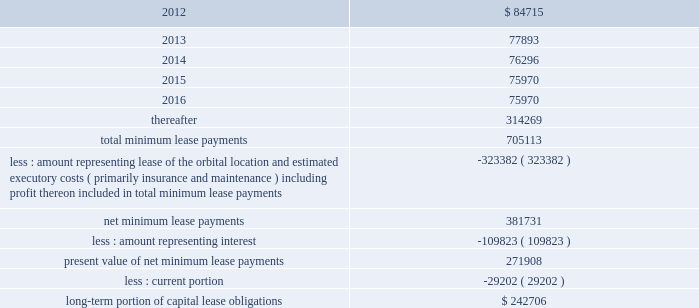Dish network corporation notes to consolidated financial statements - continued ciel ii .
Ciel ii , a canadian dbs satellite , was launched in december 2008 and commenced commercial operation during february 2009 .
This satellite is accounted for as a capital lease and depreciated over the term of the satellite service agreement .
We have leased 100% ( 100 % ) of the capacity on ciel ii for an initial 10 year term .
As of december 31 , 2011 and 2010 , we had $ 500 million capitalized for the estimated fair value of satellites acquired under capital leases included in 201cproperty and equipment , net , 201d with related accumulated depreciation of $ 151 million and $ 109 million , respectively .
In our consolidated statements of operations and comprehensive income ( loss ) , we recognized $ 43 million , $ 43 million and $ 40 million in depreciation expense on satellites acquired under capital lease agreements during the years ended december 31 , 2011 , 2010 and 2009 , respectively .
Future minimum lease payments under the capital lease obligation , together with the present value of the net minimum lease payments as of december 31 , 2011 are as follows ( in thousands ) : for the years ended december 31 .
The summary of future maturities of our outstanding long-term debt as of december 31 , 2011 is included in the commitments table in note 16 .
12 .
Income taxes and accounting for uncertainty in income taxes income taxes our income tax policy is to record the estimated future tax effects of temporary differences between the tax bases of assets and liabilities and amounts reported on our consolidated balance sheets , as well as probable operating loss , tax credit and other carryforwards .
Deferred tax assets are offset by valuation allowances when we believe it is more likely than not that net deferred tax assets will not be realized .
We periodically evaluate our need for a valuation allowance .
Determining necessary valuation allowances requires us to make assessments about historical financial information as well as the timing of future events , including the probability of expected future taxable income and available tax planning opportunities .
We file consolidated tax returns in the u.s .
The income taxes of domestic and foreign subsidiaries not included in the u.s .
Tax group are presented in our consolidated financial statements based on a separate return basis for each tax paying entity .
As of december 31 , 2011 , we had no net operating loss carryforwards ( 201cnols 201d ) for federal income tax purposes and $ 13 million of nol benefit for state income tax purposes .
The state nols begin to expire in the year 2020 .
In addition , there are $ 5 million of tax benefits related to credit carryforwards which are partially offset by a valuation allowance and $ 14 million benefit of capital loss carryforwards which are fully offset by a valuation allowance .
The credit carryforwards begin to expire in the year 2012. .
What percentage of total future minimum lease payments under the capital lease obligation is due in 2016? 
Computations: (75970 / 705113)
Answer: 0.10774. Dish network corporation notes to consolidated financial statements - continued ciel ii .
Ciel ii , a canadian dbs satellite , was launched in december 2008 and commenced commercial operation during february 2009 .
This satellite is accounted for as a capital lease and depreciated over the term of the satellite service agreement .
We have leased 100% ( 100 % ) of the capacity on ciel ii for an initial 10 year term .
As of december 31 , 2011 and 2010 , we had $ 500 million capitalized for the estimated fair value of satellites acquired under capital leases included in 201cproperty and equipment , net , 201d with related accumulated depreciation of $ 151 million and $ 109 million , respectively .
In our consolidated statements of operations and comprehensive income ( loss ) , we recognized $ 43 million , $ 43 million and $ 40 million in depreciation expense on satellites acquired under capital lease agreements during the years ended december 31 , 2011 , 2010 and 2009 , respectively .
Future minimum lease payments under the capital lease obligation , together with the present value of the net minimum lease payments as of december 31 , 2011 are as follows ( in thousands ) : for the years ended december 31 .
The summary of future maturities of our outstanding long-term debt as of december 31 , 2011 is included in the commitments table in note 16 .
12 .
Income taxes and accounting for uncertainty in income taxes income taxes our income tax policy is to record the estimated future tax effects of temporary differences between the tax bases of assets and liabilities and amounts reported on our consolidated balance sheets , as well as probable operating loss , tax credit and other carryforwards .
Deferred tax assets are offset by valuation allowances when we believe it is more likely than not that net deferred tax assets will not be realized .
We periodically evaluate our need for a valuation allowance .
Determining necessary valuation allowances requires us to make assessments about historical financial information as well as the timing of future events , including the probability of expected future taxable income and available tax planning opportunities .
We file consolidated tax returns in the u.s .
The income taxes of domestic and foreign subsidiaries not included in the u.s .
Tax group are presented in our consolidated financial statements based on a separate return basis for each tax paying entity .
As of december 31 , 2011 , we had no net operating loss carryforwards ( 201cnols 201d ) for federal income tax purposes and $ 13 million of nol benefit for state income tax purposes .
The state nols begin to expire in the year 2020 .
In addition , there are $ 5 million of tax benefits related to credit carryforwards which are partially offset by a valuation allowance and $ 14 million benefit of capital loss carryforwards which are fully offset by a valuation allowance .
The credit carryforwards begin to expire in the year 2012. .
What percentage of total future minimum lease payments under the capital lease obligation is due after 2016? 
Computations: (314269 / 705113)
Answer: 0.4457. 